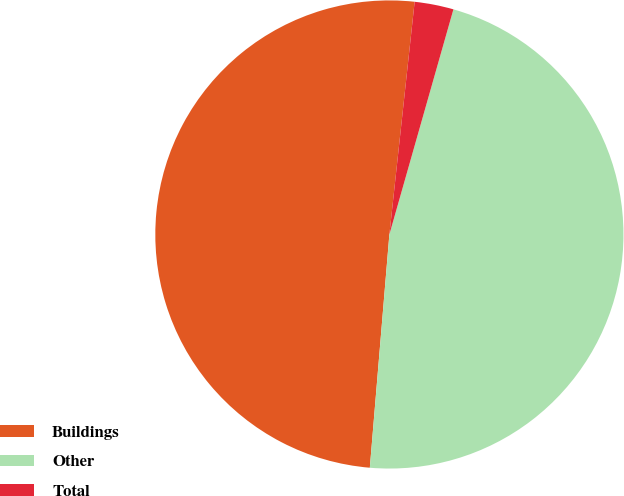Convert chart. <chart><loc_0><loc_0><loc_500><loc_500><pie_chart><fcel>Buildings<fcel>Other<fcel>Total<nl><fcel>50.39%<fcel>46.92%<fcel>2.69%<nl></chart> 